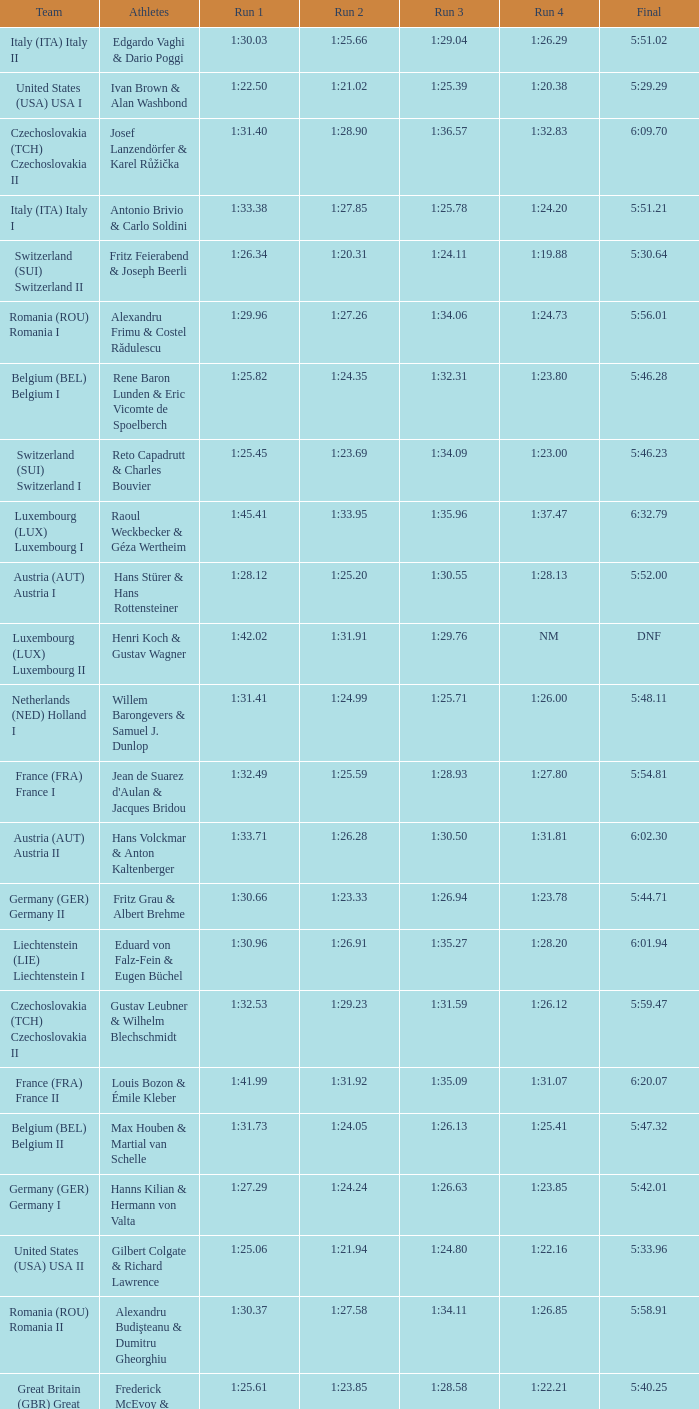Which Run 4 has a Run 3 of 1:26.63? 1:23.85. 